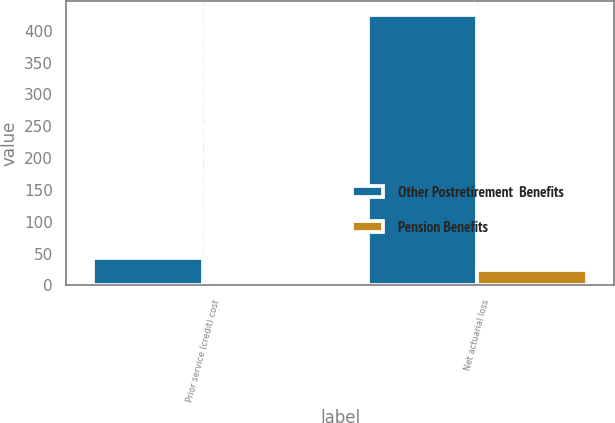Convert chart to OTSL. <chart><loc_0><loc_0><loc_500><loc_500><stacked_bar_chart><ecel><fcel>Prior service (credit) cost<fcel>Net actuarial loss<nl><fcel>Other Postretirement  Benefits<fcel>43<fcel>425<nl><fcel>Pension Benefits<fcel>6<fcel>25<nl></chart> 